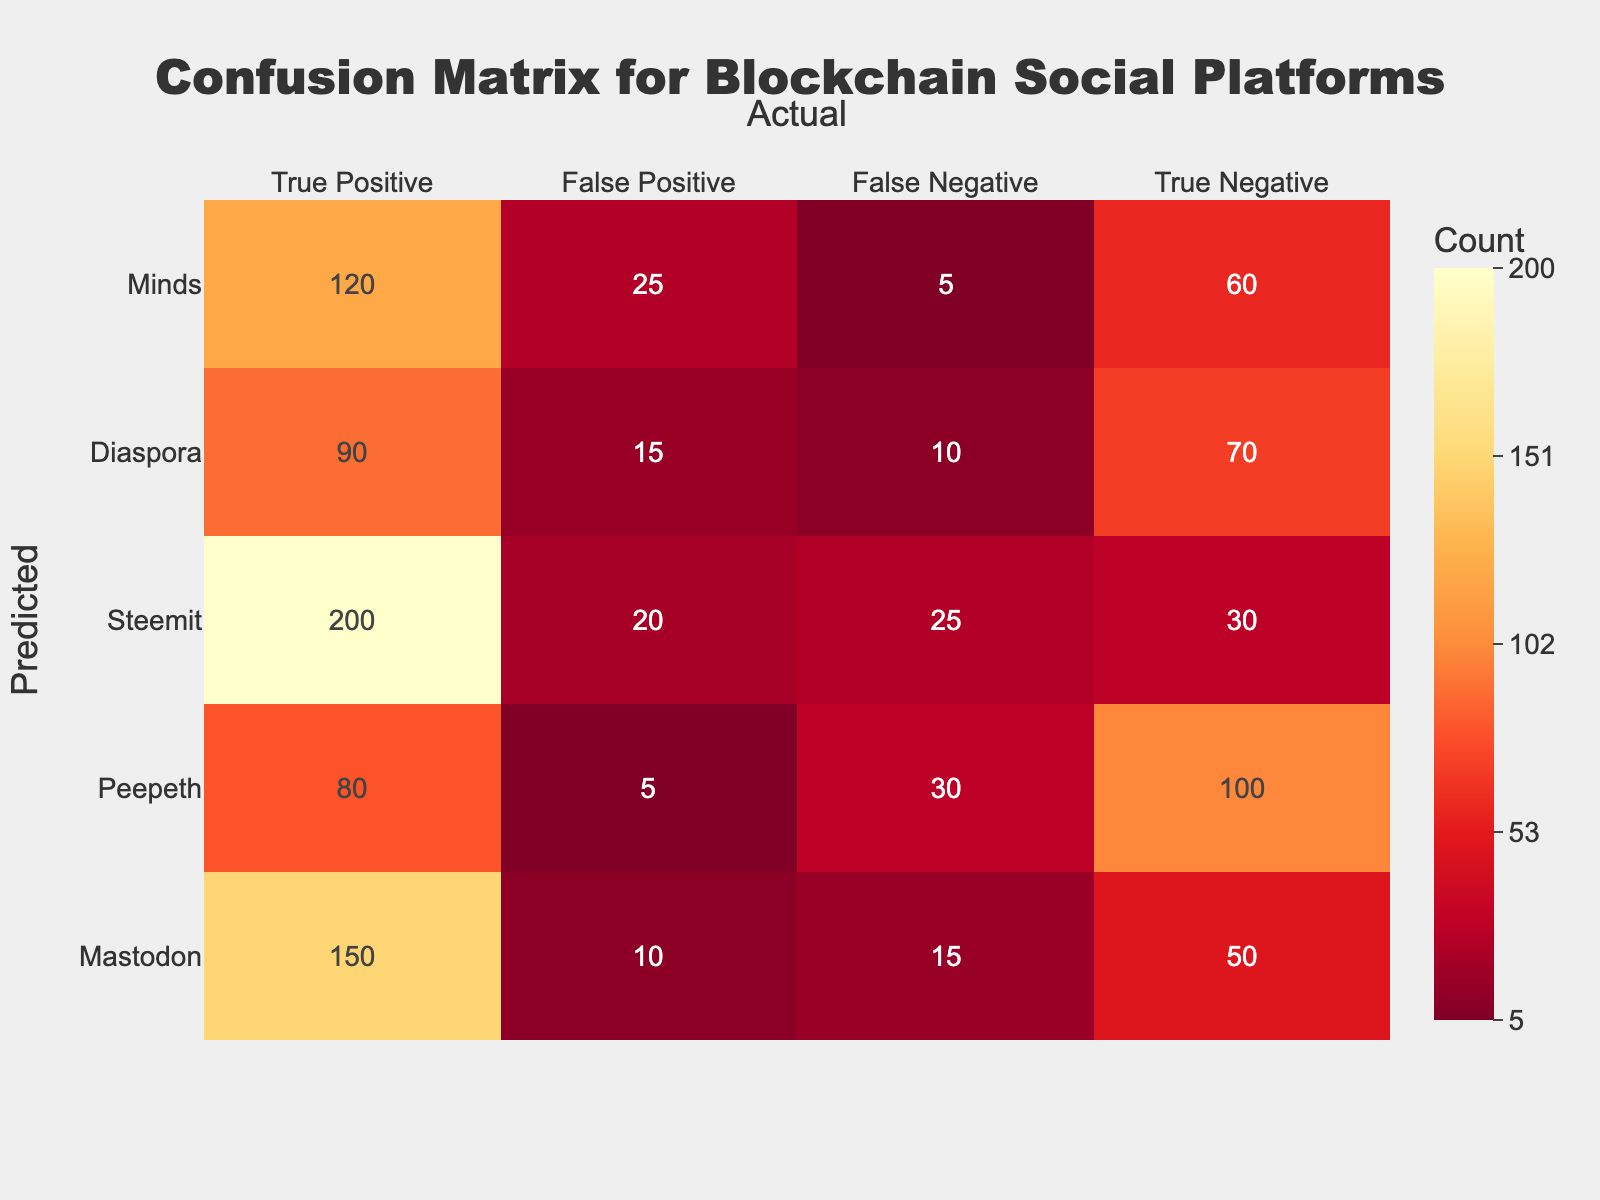What is the True Positive count for Mastodon? The table shows that under the Mastodon row, the True Positive count is listed as 150.
Answer: 150 What is the total number of False Positives across all platforms? By summing the False Positive counts for each platform: 10 (Mastodon) + 5 (Peepeth) + 20 (Steemit) + 15 (Diaspora) + 25 (Minds) = 75.
Answer: 75 Is the False Negative count for Steemit greater than the True Negative count for the same platform? The False Negative count for Steemit is 25, while the True Negative count is 30. Since 25 is less than 30, the statement is false.
Answer: No Which platform has the highest True Negative count? Reviewing the True Negative counts for all platforms, Steemit has the highest count at 30.
Answer: Steemit What is the average True Positive count for all platforms? The True Positive counts are: 150 (Mastodon) + 80 (Peepeth) + 200 (Steemit) + 90 (Diaspora) + 120 (Minds) = 640. There are 5 platforms, so the average is 640/5 = 128.
Answer: 128 Which platform has the lowest False Negative count, and what is that count? The False Negative counts are: 15 (Mastodon), 30 (Peepeth), 25 (Steemit), 10 (Diaspora), 5 (Minds). The lowest count is 5 for Minds.
Answer: Minds, 5 If we compare Peepeth and Diaspora, whose True Positive count is greater? The True Positive count for Peepeth is 80 and for Diaspora is 90. Since 90 is greater than 80, Diaspora has the greater count.
Answer: Diaspora What is the difference between the True Positive count for Steemit and the True Negative count for Diaspora? The True Positive count for Steemit is 200 and the True Negative count for Diaspora is 70. The difference is calculated as 200 - 70 = 130.
Answer: 130 How many platforms have more True Positives than False Positives? The platforms and their True and False Positive counts are: Mastodon (150, 10), Peepeth (80, 5), Steemit (200, 20), Diaspora (90, 15), Minds (120, 25). All platforms have True Positive counts greater than their False Positives: 150, 80, 200, 90, and 120 are all greater than 10, 5, 20, 15, and 25 respectively. Hence, all 5 platforms qualify.
Answer: 5 